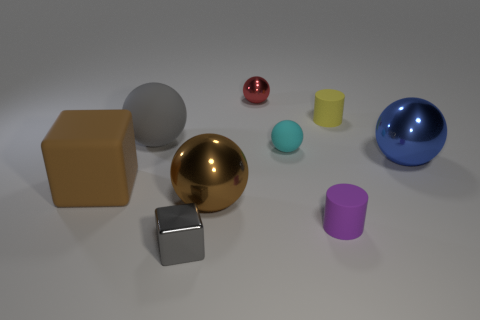Subtract all blue spheres. How many spheres are left? 4 Subtract all brown balls. How many balls are left? 4 Subtract all brown spheres. Subtract all purple cylinders. How many spheres are left? 4 Add 1 small gray metallic objects. How many objects exist? 10 Subtract all balls. How many objects are left? 4 Subtract 0 purple cubes. How many objects are left? 9 Subtract all matte cylinders. Subtract all metallic cubes. How many objects are left? 6 Add 1 gray metal things. How many gray metal things are left? 2 Add 7 large gray balls. How many large gray balls exist? 8 